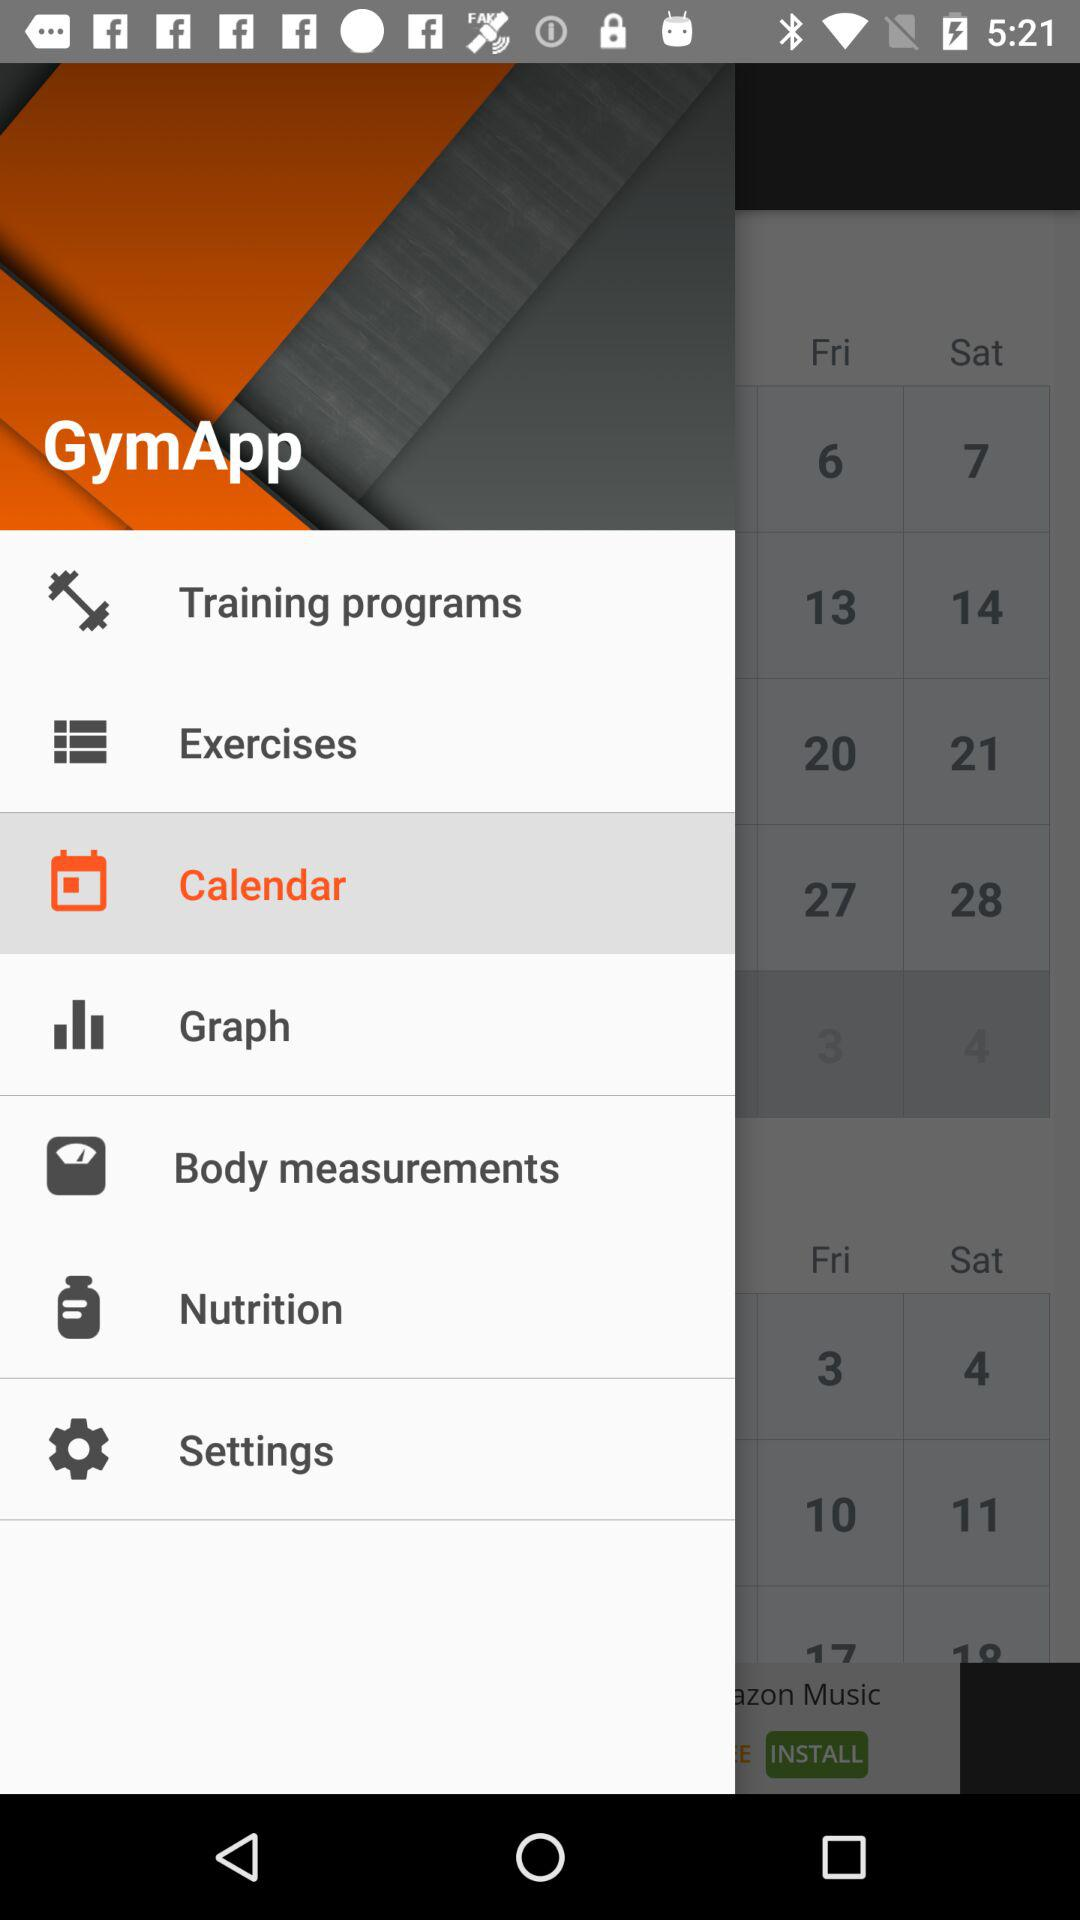What is the name of the application? The name of the application is "GymApp". 